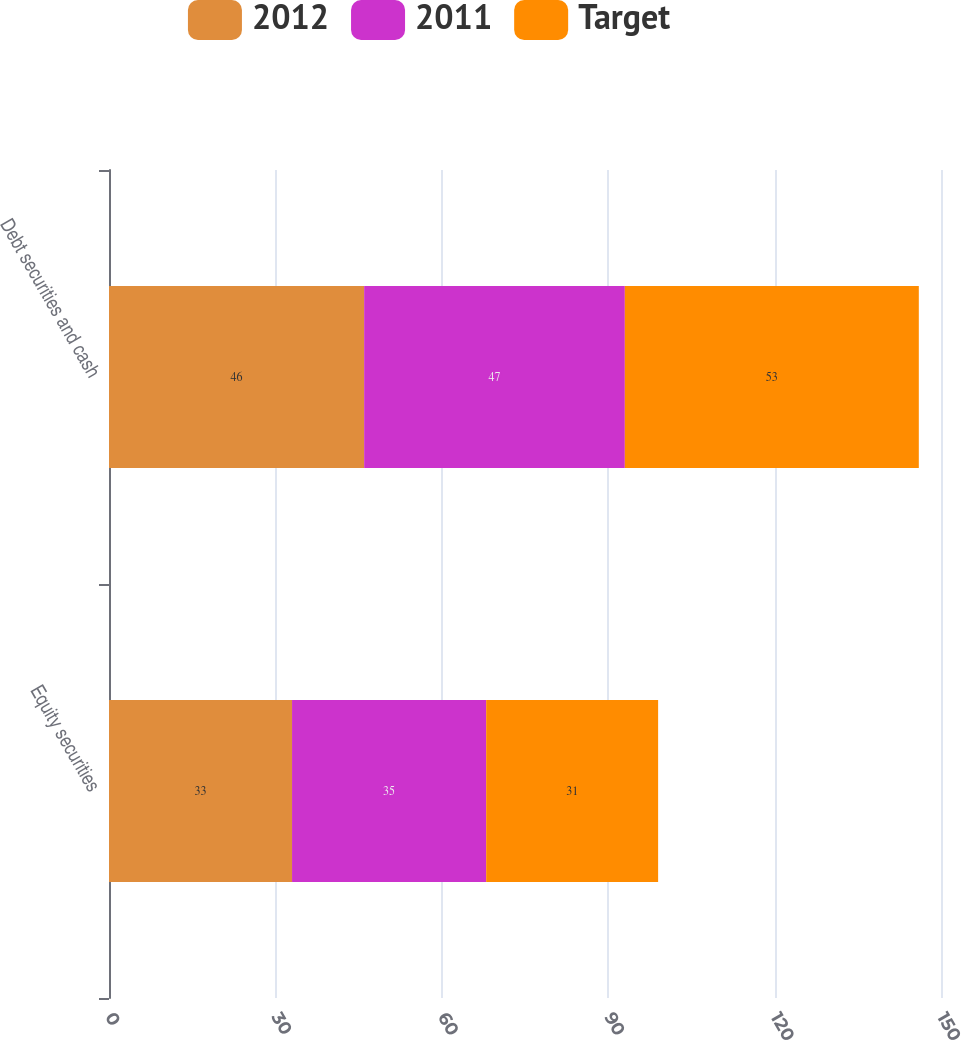<chart> <loc_0><loc_0><loc_500><loc_500><stacked_bar_chart><ecel><fcel>Equity securities<fcel>Debt securities and cash<nl><fcel>2012<fcel>33<fcel>46<nl><fcel>2011<fcel>35<fcel>47<nl><fcel>Target<fcel>31<fcel>53<nl></chart> 